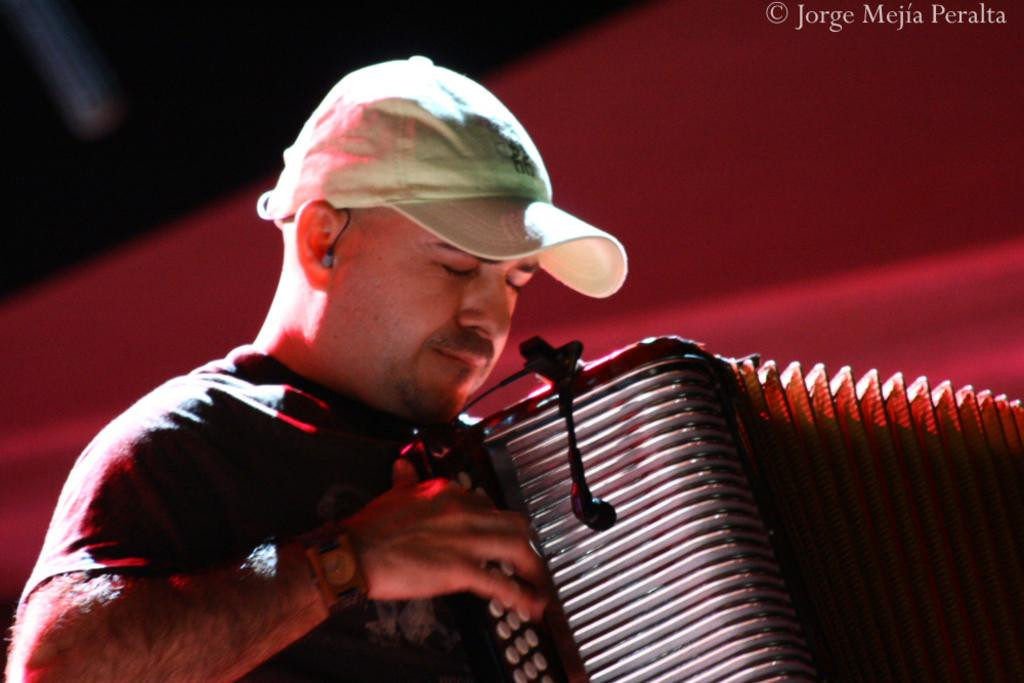What is the main subject of the image? The main subject of the image is a man. What is the man doing in the image? The man is playing a musical instrument in the image. Can you describe the man's attire in the image? The man is wearing a cap on his head in the image. How would you describe the background of the image? The background of the image is blurred. What type of oil can be seen dripping from the man's instrument in the image? There is no oil present in the image, nor is there any indication of it dripping from the man's instrument. 